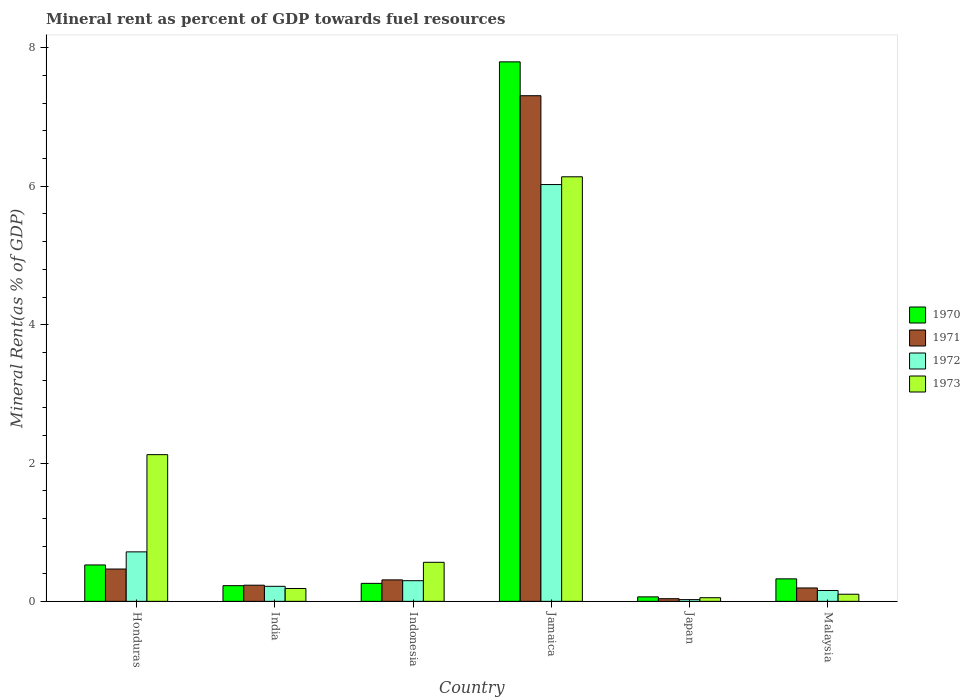How many different coloured bars are there?
Give a very brief answer. 4. What is the label of the 5th group of bars from the left?
Give a very brief answer. Japan. What is the mineral rent in 1971 in India?
Your answer should be very brief. 0.23. Across all countries, what is the maximum mineral rent in 1970?
Your answer should be very brief. 7.8. Across all countries, what is the minimum mineral rent in 1970?
Ensure brevity in your answer.  0.06. In which country was the mineral rent in 1971 maximum?
Provide a short and direct response. Jamaica. What is the total mineral rent in 1970 in the graph?
Keep it short and to the point. 9.2. What is the difference between the mineral rent in 1972 in Jamaica and that in Malaysia?
Offer a very short reply. 5.87. What is the difference between the mineral rent in 1973 in Japan and the mineral rent in 1970 in India?
Your response must be concise. -0.17. What is the average mineral rent in 1970 per country?
Your answer should be compact. 1.53. What is the difference between the mineral rent of/in 1972 and mineral rent of/in 1973 in Malaysia?
Offer a very short reply. 0.05. In how many countries, is the mineral rent in 1970 greater than 6 %?
Your response must be concise. 1. What is the ratio of the mineral rent in 1970 in India to that in Japan?
Give a very brief answer. 3.5. What is the difference between the highest and the second highest mineral rent in 1970?
Your answer should be compact. 0.2. What is the difference between the highest and the lowest mineral rent in 1970?
Your answer should be very brief. 7.73. Is the sum of the mineral rent in 1973 in India and Japan greater than the maximum mineral rent in 1970 across all countries?
Ensure brevity in your answer.  No. Is it the case that in every country, the sum of the mineral rent in 1973 and mineral rent in 1972 is greater than the sum of mineral rent in 1971 and mineral rent in 1970?
Offer a terse response. No. What does the 1st bar from the left in India represents?
Offer a terse response. 1970. Is it the case that in every country, the sum of the mineral rent in 1972 and mineral rent in 1971 is greater than the mineral rent in 1970?
Give a very brief answer. No. Are all the bars in the graph horizontal?
Offer a terse response. No. What is the difference between two consecutive major ticks on the Y-axis?
Offer a terse response. 2. Does the graph contain any zero values?
Your response must be concise. No. Where does the legend appear in the graph?
Offer a very short reply. Center right. How are the legend labels stacked?
Offer a terse response. Vertical. What is the title of the graph?
Offer a very short reply. Mineral rent as percent of GDP towards fuel resources. Does "1977" appear as one of the legend labels in the graph?
Your answer should be very brief. No. What is the label or title of the Y-axis?
Offer a very short reply. Mineral Rent(as % of GDP). What is the Mineral Rent(as % of GDP) of 1970 in Honduras?
Your answer should be compact. 0.53. What is the Mineral Rent(as % of GDP) of 1971 in Honduras?
Keep it short and to the point. 0.47. What is the Mineral Rent(as % of GDP) in 1972 in Honduras?
Provide a succinct answer. 0.72. What is the Mineral Rent(as % of GDP) in 1973 in Honduras?
Offer a terse response. 2.12. What is the Mineral Rent(as % of GDP) of 1970 in India?
Keep it short and to the point. 0.23. What is the Mineral Rent(as % of GDP) of 1971 in India?
Offer a terse response. 0.23. What is the Mineral Rent(as % of GDP) of 1972 in India?
Your response must be concise. 0.22. What is the Mineral Rent(as % of GDP) in 1973 in India?
Offer a terse response. 0.19. What is the Mineral Rent(as % of GDP) of 1970 in Indonesia?
Provide a short and direct response. 0.26. What is the Mineral Rent(as % of GDP) of 1971 in Indonesia?
Ensure brevity in your answer.  0.31. What is the Mineral Rent(as % of GDP) in 1972 in Indonesia?
Give a very brief answer. 0.3. What is the Mineral Rent(as % of GDP) in 1973 in Indonesia?
Your answer should be very brief. 0.56. What is the Mineral Rent(as % of GDP) in 1970 in Jamaica?
Give a very brief answer. 7.8. What is the Mineral Rent(as % of GDP) in 1971 in Jamaica?
Your answer should be very brief. 7.31. What is the Mineral Rent(as % of GDP) in 1972 in Jamaica?
Provide a succinct answer. 6.03. What is the Mineral Rent(as % of GDP) of 1973 in Jamaica?
Provide a short and direct response. 6.14. What is the Mineral Rent(as % of GDP) in 1970 in Japan?
Give a very brief answer. 0.06. What is the Mineral Rent(as % of GDP) of 1971 in Japan?
Provide a short and direct response. 0.04. What is the Mineral Rent(as % of GDP) of 1972 in Japan?
Offer a very short reply. 0.03. What is the Mineral Rent(as % of GDP) of 1973 in Japan?
Provide a short and direct response. 0.05. What is the Mineral Rent(as % of GDP) in 1970 in Malaysia?
Offer a very short reply. 0.33. What is the Mineral Rent(as % of GDP) in 1971 in Malaysia?
Provide a short and direct response. 0.19. What is the Mineral Rent(as % of GDP) in 1972 in Malaysia?
Make the answer very short. 0.16. What is the Mineral Rent(as % of GDP) of 1973 in Malaysia?
Your response must be concise. 0.1. Across all countries, what is the maximum Mineral Rent(as % of GDP) in 1970?
Offer a terse response. 7.8. Across all countries, what is the maximum Mineral Rent(as % of GDP) in 1971?
Provide a short and direct response. 7.31. Across all countries, what is the maximum Mineral Rent(as % of GDP) of 1972?
Offer a very short reply. 6.03. Across all countries, what is the maximum Mineral Rent(as % of GDP) in 1973?
Offer a very short reply. 6.14. Across all countries, what is the minimum Mineral Rent(as % of GDP) in 1970?
Offer a very short reply. 0.06. Across all countries, what is the minimum Mineral Rent(as % of GDP) of 1971?
Provide a succinct answer. 0.04. Across all countries, what is the minimum Mineral Rent(as % of GDP) of 1972?
Your answer should be very brief. 0.03. Across all countries, what is the minimum Mineral Rent(as % of GDP) of 1973?
Give a very brief answer. 0.05. What is the total Mineral Rent(as % of GDP) in 1970 in the graph?
Ensure brevity in your answer.  9.2. What is the total Mineral Rent(as % of GDP) in 1971 in the graph?
Your answer should be very brief. 8.55. What is the total Mineral Rent(as % of GDP) in 1972 in the graph?
Give a very brief answer. 7.44. What is the total Mineral Rent(as % of GDP) of 1973 in the graph?
Make the answer very short. 9.17. What is the difference between the Mineral Rent(as % of GDP) in 1970 in Honduras and that in India?
Offer a very short reply. 0.3. What is the difference between the Mineral Rent(as % of GDP) in 1971 in Honduras and that in India?
Your answer should be very brief. 0.23. What is the difference between the Mineral Rent(as % of GDP) of 1972 in Honduras and that in India?
Make the answer very short. 0.5. What is the difference between the Mineral Rent(as % of GDP) of 1973 in Honduras and that in India?
Offer a very short reply. 1.94. What is the difference between the Mineral Rent(as % of GDP) of 1970 in Honduras and that in Indonesia?
Provide a short and direct response. 0.27. What is the difference between the Mineral Rent(as % of GDP) in 1971 in Honduras and that in Indonesia?
Provide a short and direct response. 0.16. What is the difference between the Mineral Rent(as % of GDP) of 1972 in Honduras and that in Indonesia?
Keep it short and to the point. 0.42. What is the difference between the Mineral Rent(as % of GDP) in 1973 in Honduras and that in Indonesia?
Your answer should be very brief. 1.56. What is the difference between the Mineral Rent(as % of GDP) in 1970 in Honduras and that in Jamaica?
Your response must be concise. -7.27. What is the difference between the Mineral Rent(as % of GDP) in 1971 in Honduras and that in Jamaica?
Make the answer very short. -6.84. What is the difference between the Mineral Rent(as % of GDP) of 1972 in Honduras and that in Jamaica?
Ensure brevity in your answer.  -5.31. What is the difference between the Mineral Rent(as % of GDP) of 1973 in Honduras and that in Jamaica?
Ensure brevity in your answer.  -4.02. What is the difference between the Mineral Rent(as % of GDP) of 1970 in Honduras and that in Japan?
Keep it short and to the point. 0.46. What is the difference between the Mineral Rent(as % of GDP) of 1971 in Honduras and that in Japan?
Provide a succinct answer. 0.43. What is the difference between the Mineral Rent(as % of GDP) of 1972 in Honduras and that in Japan?
Keep it short and to the point. 0.69. What is the difference between the Mineral Rent(as % of GDP) in 1973 in Honduras and that in Japan?
Ensure brevity in your answer.  2.07. What is the difference between the Mineral Rent(as % of GDP) of 1970 in Honduras and that in Malaysia?
Your response must be concise. 0.2. What is the difference between the Mineral Rent(as % of GDP) of 1971 in Honduras and that in Malaysia?
Offer a very short reply. 0.27. What is the difference between the Mineral Rent(as % of GDP) of 1972 in Honduras and that in Malaysia?
Offer a very short reply. 0.56. What is the difference between the Mineral Rent(as % of GDP) in 1973 in Honduras and that in Malaysia?
Your response must be concise. 2.02. What is the difference between the Mineral Rent(as % of GDP) of 1970 in India and that in Indonesia?
Offer a very short reply. -0.03. What is the difference between the Mineral Rent(as % of GDP) of 1971 in India and that in Indonesia?
Provide a short and direct response. -0.08. What is the difference between the Mineral Rent(as % of GDP) in 1972 in India and that in Indonesia?
Give a very brief answer. -0.08. What is the difference between the Mineral Rent(as % of GDP) in 1973 in India and that in Indonesia?
Your answer should be compact. -0.38. What is the difference between the Mineral Rent(as % of GDP) in 1970 in India and that in Jamaica?
Give a very brief answer. -7.57. What is the difference between the Mineral Rent(as % of GDP) of 1971 in India and that in Jamaica?
Offer a terse response. -7.08. What is the difference between the Mineral Rent(as % of GDP) of 1972 in India and that in Jamaica?
Provide a succinct answer. -5.81. What is the difference between the Mineral Rent(as % of GDP) in 1973 in India and that in Jamaica?
Your response must be concise. -5.95. What is the difference between the Mineral Rent(as % of GDP) in 1970 in India and that in Japan?
Your response must be concise. 0.16. What is the difference between the Mineral Rent(as % of GDP) of 1971 in India and that in Japan?
Make the answer very short. 0.2. What is the difference between the Mineral Rent(as % of GDP) in 1972 in India and that in Japan?
Make the answer very short. 0.19. What is the difference between the Mineral Rent(as % of GDP) of 1973 in India and that in Japan?
Your response must be concise. 0.13. What is the difference between the Mineral Rent(as % of GDP) of 1970 in India and that in Malaysia?
Make the answer very short. -0.1. What is the difference between the Mineral Rent(as % of GDP) in 1971 in India and that in Malaysia?
Make the answer very short. 0.04. What is the difference between the Mineral Rent(as % of GDP) in 1972 in India and that in Malaysia?
Your answer should be very brief. 0.06. What is the difference between the Mineral Rent(as % of GDP) of 1973 in India and that in Malaysia?
Ensure brevity in your answer.  0.08. What is the difference between the Mineral Rent(as % of GDP) of 1970 in Indonesia and that in Jamaica?
Ensure brevity in your answer.  -7.54. What is the difference between the Mineral Rent(as % of GDP) of 1971 in Indonesia and that in Jamaica?
Your answer should be compact. -7. What is the difference between the Mineral Rent(as % of GDP) in 1972 in Indonesia and that in Jamaica?
Provide a short and direct response. -5.73. What is the difference between the Mineral Rent(as % of GDP) in 1973 in Indonesia and that in Jamaica?
Keep it short and to the point. -5.57. What is the difference between the Mineral Rent(as % of GDP) of 1970 in Indonesia and that in Japan?
Your answer should be compact. 0.2. What is the difference between the Mineral Rent(as % of GDP) of 1971 in Indonesia and that in Japan?
Make the answer very short. 0.27. What is the difference between the Mineral Rent(as % of GDP) in 1972 in Indonesia and that in Japan?
Your answer should be compact. 0.27. What is the difference between the Mineral Rent(as % of GDP) of 1973 in Indonesia and that in Japan?
Ensure brevity in your answer.  0.51. What is the difference between the Mineral Rent(as % of GDP) of 1970 in Indonesia and that in Malaysia?
Provide a short and direct response. -0.07. What is the difference between the Mineral Rent(as % of GDP) of 1971 in Indonesia and that in Malaysia?
Make the answer very short. 0.12. What is the difference between the Mineral Rent(as % of GDP) of 1972 in Indonesia and that in Malaysia?
Provide a succinct answer. 0.14. What is the difference between the Mineral Rent(as % of GDP) of 1973 in Indonesia and that in Malaysia?
Provide a succinct answer. 0.46. What is the difference between the Mineral Rent(as % of GDP) of 1970 in Jamaica and that in Japan?
Offer a very short reply. 7.73. What is the difference between the Mineral Rent(as % of GDP) of 1971 in Jamaica and that in Japan?
Ensure brevity in your answer.  7.27. What is the difference between the Mineral Rent(as % of GDP) in 1972 in Jamaica and that in Japan?
Offer a terse response. 6. What is the difference between the Mineral Rent(as % of GDP) in 1973 in Jamaica and that in Japan?
Keep it short and to the point. 6.08. What is the difference between the Mineral Rent(as % of GDP) in 1970 in Jamaica and that in Malaysia?
Offer a very short reply. 7.47. What is the difference between the Mineral Rent(as % of GDP) of 1971 in Jamaica and that in Malaysia?
Offer a terse response. 7.12. What is the difference between the Mineral Rent(as % of GDP) in 1972 in Jamaica and that in Malaysia?
Your answer should be very brief. 5.87. What is the difference between the Mineral Rent(as % of GDP) of 1973 in Jamaica and that in Malaysia?
Your response must be concise. 6.03. What is the difference between the Mineral Rent(as % of GDP) of 1970 in Japan and that in Malaysia?
Give a very brief answer. -0.26. What is the difference between the Mineral Rent(as % of GDP) of 1971 in Japan and that in Malaysia?
Provide a succinct answer. -0.16. What is the difference between the Mineral Rent(as % of GDP) of 1972 in Japan and that in Malaysia?
Your answer should be very brief. -0.13. What is the difference between the Mineral Rent(as % of GDP) in 1973 in Japan and that in Malaysia?
Your answer should be compact. -0.05. What is the difference between the Mineral Rent(as % of GDP) of 1970 in Honduras and the Mineral Rent(as % of GDP) of 1971 in India?
Your answer should be very brief. 0.29. What is the difference between the Mineral Rent(as % of GDP) in 1970 in Honduras and the Mineral Rent(as % of GDP) in 1972 in India?
Make the answer very short. 0.31. What is the difference between the Mineral Rent(as % of GDP) in 1970 in Honduras and the Mineral Rent(as % of GDP) in 1973 in India?
Offer a terse response. 0.34. What is the difference between the Mineral Rent(as % of GDP) of 1971 in Honduras and the Mineral Rent(as % of GDP) of 1972 in India?
Ensure brevity in your answer.  0.25. What is the difference between the Mineral Rent(as % of GDP) in 1971 in Honduras and the Mineral Rent(as % of GDP) in 1973 in India?
Your answer should be very brief. 0.28. What is the difference between the Mineral Rent(as % of GDP) of 1972 in Honduras and the Mineral Rent(as % of GDP) of 1973 in India?
Provide a short and direct response. 0.53. What is the difference between the Mineral Rent(as % of GDP) of 1970 in Honduras and the Mineral Rent(as % of GDP) of 1971 in Indonesia?
Your response must be concise. 0.22. What is the difference between the Mineral Rent(as % of GDP) of 1970 in Honduras and the Mineral Rent(as % of GDP) of 1972 in Indonesia?
Your response must be concise. 0.23. What is the difference between the Mineral Rent(as % of GDP) in 1970 in Honduras and the Mineral Rent(as % of GDP) in 1973 in Indonesia?
Keep it short and to the point. -0.04. What is the difference between the Mineral Rent(as % of GDP) in 1971 in Honduras and the Mineral Rent(as % of GDP) in 1972 in Indonesia?
Provide a succinct answer. 0.17. What is the difference between the Mineral Rent(as % of GDP) of 1971 in Honduras and the Mineral Rent(as % of GDP) of 1973 in Indonesia?
Provide a succinct answer. -0.1. What is the difference between the Mineral Rent(as % of GDP) of 1972 in Honduras and the Mineral Rent(as % of GDP) of 1973 in Indonesia?
Make the answer very short. 0.15. What is the difference between the Mineral Rent(as % of GDP) in 1970 in Honduras and the Mineral Rent(as % of GDP) in 1971 in Jamaica?
Ensure brevity in your answer.  -6.78. What is the difference between the Mineral Rent(as % of GDP) of 1970 in Honduras and the Mineral Rent(as % of GDP) of 1972 in Jamaica?
Give a very brief answer. -5.5. What is the difference between the Mineral Rent(as % of GDP) of 1970 in Honduras and the Mineral Rent(as % of GDP) of 1973 in Jamaica?
Offer a very short reply. -5.61. What is the difference between the Mineral Rent(as % of GDP) in 1971 in Honduras and the Mineral Rent(as % of GDP) in 1972 in Jamaica?
Ensure brevity in your answer.  -5.56. What is the difference between the Mineral Rent(as % of GDP) of 1971 in Honduras and the Mineral Rent(as % of GDP) of 1973 in Jamaica?
Your answer should be compact. -5.67. What is the difference between the Mineral Rent(as % of GDP) in 1972 in Honduras and the Mineral Rent(as % of GDP) in 1973 in Jamaica?
Offer a very short reply. -5.42. What is the difference between the Mineral Rent(as % of GDP) of 1970 in Honduras and the Mineral Rent(as % of GDP) of 1971 in Japan?
Offer a terse response. 0.49. What is the difference between the Mineral Rent(as % of GDP) of 1970 in Honduras and the Mineral Rent(as % of GDP) of 1972 in Japan?
Ensure brevity in your answer.  0.5. What is the difference between the Mineral Rent(as % of GDP) in 1970 in Honduras and the Mineral Rent(as % of GDP) in 1973 in Japan?
Your response must be concise. 0.47. What is the difference between the Mineral Rent(as % of GDP) of 1971 in Honduras and the Mineral Rent(as % of GDP) of 1972 in Japan?
Your answer should be compact. 0.44. What is the difference between the Mineral Rent(as % of GDP) in 1971 in Honduras and the Mineral Rent(as % of GDP) in 1973 in Japan?
Provide a succinct answer. 0.41. What is the difference between the Mineral Rent(as % of GDP) in 1972 in Honduras and the Mineral Rent(as % of GDP) in 1973 in Japan?
Your answer should be compact. 0.66. What is the difference between the Mineral Rent(as % of GDP) in 1970 in Honduras and the Mineral Rent(as % of GDP) in 1971 in Malaysia?
Offer a very short reply. 0.33. What is the difference between the Mineral Rent(as % of GDP) in 1970 in Honduras and the Mineral Rent(as % of GDP) in 1972 in Malaysia?
Keep it short and to the point. 0.37. What is the difference between the Mineral Rent(as % of GDP) in 1970 in Honduras and the Mineral Rent(as % of GDP) in 1973 in Malaysia?
Keep it short and to the point. 0.42. What is the difference between the Mineral Rent(as % of GDP) in 1971 in Honduras and the Mineral Rent(as % of GDP) in 1972 in Malaysia?
Your response must be concise. 0.31. What is the difference between the Mineral Rent(as % of GDP) in 1971 in Honduras and the Mineral Rent(as % of GDP) in 1973 in Malaysia?
Your response must be concise. 0.36. What is the difference between the Mineral Rent(as % of GDP) in 1972 in Honduras and the Mineral Rent(as % of GDP) in 1973 in Malaysia?
Offer a very short reply. 0.61. What is the difference between the Mineral Rent(as % of GDP) of 1970 in India and the Mineral Rent(as % of GDP) of 1971 in Indonesia?
Offer a very short reply. -0.08. What is the difference between the Mineral Rent(as % of GDP) of 1970 in India and the Mineral Rent(as % of GDP) of 1972 in Indonesia?
Give a very brief answer. -0.07. What is the difference between the Mineral Rent(as % of GDP) of 1970 in India and the Mineral Rent(as % of GDP) of 1973 in Indonesia?
Offer a very short reply. -0.34. What is the difference between the Mineral Rent(as % of GDP) in 1971 in India and the Mineral Rent(as % of GDP) in 1972 in Indonesia?
Give a very brief answer. -0.07. What is the difference between the Mineral Rent(as % of GDP) in 1971 in India and the Mineral Rent(as % of GDP) in 1973 in Indonesia?
Make the answer very short. -0.33. What is the difference between the Mineral Rent(as % of GDP) in 1972 in India and the Mineral Rent(as % of GDP) in 1973 in Indonesia?
Give a very brief answer. -0.35. What is the difference between the Mineral Rent(as % of GDP) of 1970 in India and the Mineral Rent(as % of GDP) of 1971 in Jamaica?
Offer a very short reply. -7.08. What is the difference between the Mineral Rent(as % of GDP) in 1970 in India and the Mineral Rent(as % of GDP) in 1972 in Jamaica?
Keep it short and to the point. -5.8. What is the difference between the Mineral Rent(as % of GDP) of 1970 in India and the Mineral Rent(as % of GDP) of 1973 in Jamaica?
Your answer should be compact. -5.91. What is the difference between the Mineral Rent(as % of GDP) of 1971 in India and the Mineral Rent(as % of GDP) of 1972 in Jamaica?
Make the answer very short. -5.79. What is the difference between the Mineral Rent(as % of GDP) in 1971 in India and the Mineral Rent(as % of GDP) in 1973 in Jamaica?
Keep it short and to the point. -5.9. What is the difference between the Mineral Rent(as % of GDP) in 1972 in India and the Mineral Rent(as % of GDP) in 1973 in Jamaica?
Your answer should be very brief. -5.92. What is the difference between the Mineral Rent(as % of GDP) in 1970 in India and the Mineral Rent(as % of GDP) in 1971 in Japan?
Provide a succinct answer. 0.19. What is the difference between the Mineral Rent(as % of GDP) of 1970 in India and the Mineral Rent(as % of GDP) of 1972 in Japan?
Provide a short and direct response. 0.2. What is the difference between the Mineral Rent(as % of GDP) of 1970 in India and the Mineral Rent(as % of GDP) of 1973 in Japan?
Your response must be concise. 0.17. What is the difference between the Mineral Rent(as % of GDP) in 1971 in India and the Mineral Rent(as % of GDP) in 1972 in Japan?
Your response must be concise. 0.21. What is the difference between the Mineral Rent(as % of GDP) in 1971 in India and the Mineral Rent(as % of GDP) in 1973 in Japan?
Give a very brief answer. 0.18. What is the difference between the Mineral Rent(as % of GDP) of 1972 in India and the Mineral Rent(as % of GDP) of 1973 in Japan?
Your answer should be very brief. 0.16. What is the difference between the Mineral Rent(as % of GDP) in 1970 in India and the Mineral Rent(as % of GDP) in 1972 in Malaysia?
Make the answer very short. 0.07. What is the difference between the Mineral Rent(as % of GDP) of 1970 in India and the Mineral Rent(as % of GDP) of 1973 in Malaysia?
Your answer should be compact. 0.12. What is the difference between the Mineral Rent(as % of GDP) of 1971 in India and the Mineral Rent(as % of GDP) of 1972 in Malaysia?
Your answer should be compact. 0.08. What is the difference between the Mineral Rent(as % of GDP) in 1971 in India and the Mineral Rent(as % of GDP) in 1973 in Malaysia?
Make the answer very short. 0.13. What is the difference between the Mineral Rent(as % of GDP) in 1972 in India and the Mineral Rent(as % of GDP) in 1973 in Malaysia?
Provide a short and direct response. 0.11. What is the difference between the Mineral Rent(as % of GDP) of 1970 in Indonesia and the Mineral Rent(as % of GDP) of 1971 in Jamaica?
Your answer should be compact. -7.05. What is the difference between the Mineral Rent(as % of GDP) in 1970 in Indonesia and the Mineral Rent(as % of GDP) in 1972 in Jamaica?
Offer a terse response. -5.77. What is the difference between the Mineral Rent(as % of GDP) in 1970 in Indonesia and the Mineral Rent(as % of GDP) in 1973 in Jamaica?
Offer a terse response. -5.88. What is the difference between the Mineral Rent(as % of GDP) of 1971 in Indonesia and the Mineral Rent(as % of GDP) of 1972 in Jamaica?
Your answer should be compact. -5.72. What is the difference between the Mineral Rent(as % of GDP) in 1971 in Indonesia and the Mineral Rent(as % of GDP) in 1973 in Jamaica?
Offer a very short reply. -5.83. What is the difference between the Mineral Rent(as % of GDP) of 1972 in Indonesia and the Mineral Rent(as % of GDP) of 1973 in Jamaica?
Keep it short and to the point. -5.84. What is the difference between the Mineral Rent(as % of GDP) in 1970 in Indonesia and the Mineral Rent(as % of GDP) in 1971 in Japan?
Your answer should be very brief. 0.22. What is the difference between the Mineral Rent(as % of GDP) in 1970 in Indonesia and the Mineral Rent(as % of GDP) in 1972 in Japan?
Keep it short and to the point. 0.23. What is the difference between the Mineral Rent(as % of GDP) of 1970 in Indonesia and the Mineral Rent(as % of GDP) of 1973 in Japan?
Offer a terse response. 0.21. What is the difference between the Mineral Rent(as % of GDP) in 1971 in Indonesia and the Mineral Rent(as % of GDP) in 1972 in Japan?
Keep it short and to the point. 0.29. What is the difference between the Mineral Rent(as % of GDP) in 1971 in Indonesia and the Mineral Rent(as % of GDP) in 1973 in Japan?
Keep it short and to the point. 0.26. What is the difference between the Mineral Rent(as % of GDP) of 1972 in Indonesia and the Mineral Rent(as % of GDP) of 1973 in Japan?
Give a very brief answer. 0.25. What is the difference between the Mineral Rent(as % of GDP) of 1970 in Indonesia and the Mineral Rent(as % of GDP) of 1971 in Malaysia?
Give a very brief answer. 0.07. What is the difference between the Mineral Rent(as % of GDP) of 1970 in Indonesia and the Mineral Rent(as % of GDP) of 1972 in Malaysia?
Your response must be concise. 0.1. What is the difference between the Mineral Rent(as % of GDP) in 1970 in Indonesia and the Mineral Rent(as % of GDP) in 1973 in Malaysia?
Offer a very short reply. 0.16. What is the difference between the Mineral Rent(as % of GDP) of 1971 in Indonesia and the Mineral Rent(as % of GDP) of 1972 in Malaysia?
Make the answer very short. 0.15. What is the difference between the Mineral Rent(as % of GDP) of 1971 in Indonesia and the Mineral Rent(as % of GDP) of 1973 in Malaysia?
Keep it short and to the point. 0.21. What is the difference between the Mineral Rent(as % of GDP) in 1972 in Indonesia and the Mineral Rent(as % of GDP) in 1973 in Malaysia?
Your answer should be very brief. 0.2. What is the difference between the Mineral Rent(as % of GDP) in 1970 in Jamaica and the Mineral Rent(as % of GDP) in 1971 in Japan?
Make the answer very short. 7.76. What is the difference between the Mineral Rent(as % of GDP) in 1970 in Jamaica and the Mineral Rent(as % of GDP) in 1972 in Japan?
Give a very brief answer. 7.77. What is the difference between the Mineral Rent(as % of GDP) of 1970 in Jamaica and the Mineral Rent(as % of GDP) of 1973 in Japan?
Your answer should be compact. 7.75. What is the difference between the Mineral Rent(as % of GDP) of 1971 in Jamaica and the Mineral Rent(as % of GDP) of 1972 in Japan?
Keep it short and to the point. 7.28. What is the difference between the Mineral Rent(as % of GDP) in 1971 in Jamaica and the Mineral Rent(as % of GDP) in 1973 in Japan?
Keep it short and to the point. 7.26. What is the difference between the Mineral Rent(as % of GDP) of 1972 in Jamaica and the Mineral Rent(as % of GDP) of 1973 in Japan?
Give a very brief answer. 5.97. What is the difference between the Mineral Rent(as % of GDP) of 1970 in Jamaica and the Mineral Rent(as % of GDP) of 1971 in Malaysia?
Your response must be concise. 7.61. What is the difference between the Mineral Rent(as % of GDP) of 1970 in Jamaica and the Mineral Rent(as % of GDP) of 1972 in Malaysia?
Provide a short and direct response. 7.64. What is the difference between the Mineral Rent(as % of GDP) in 1970 in Jamaica and the Mineral Rent(as % of GDP) in 1973 in Malaysia?
Provide a short and direct response. 7.7. What is the difference between the Mineral Rent(as % of GDP) in 1971 in Jamaica and the Mineral Rent(as % of GDP) in 1972 in Malaysia?
Give a very brief answer. 7.15. What is the difference between the Mineral Rent(as % of GDP) in 1971 in Jamaica and the Mineral Rent(as % of GDP) in 1973 in Malaysia?
Your response must be concise. 7.21. What is the difference between the Mineral Rent(as % of GDP) in 1972 in Jamaica and the Mineral Rent(as % of GDP) in 1973 in Malaysia?
Your answer should be compact. 5.92. What is the difference between the Mineral Rent(as % of GDP) of 1970 in Japan and the Mineral Rent(as % of GDP) of 1971 in Malaysia?
Provide a short and direct response. -0.13. What is the difference between the Mineral Rent(as % of GDP) in 1970 in Japan and the Mineral Rent(as % of GDP) in 1972 in Malaysia?
Make the answer very short. -0.09. What is the difference between the Mineral Rent(as % of GDP) of 1970 in Japan and the Mineral Rent(as % of GDP) of 1973 in Malaysia?
Keep it short and to the point. -0.04. What is the difference between the Mineral Rent(as % of GDP) in 1971 in Japan and the Mineral Rent(as % of GDP) in 1972 in Malaysia?
Ensure brevity in your answer.  -0.12. What is the difference between the Mineral Rent(as % of GDP) of 1971 in Japan and the Mineral Rent(as % of GDP) of 1973 in Malaysia?
Ensure brevity in your answer.  -0.06. What is the difference between the Mineral Rent(as % of GDP) in 1972 in Japan and the Mineral Rent(as % of GDP) in 1973 in Malaysia?
Make the answer very short. -0.08. What is the average Mineral Rent(as % of GDP) in 1970 per country?
Provide a succinct answer. 1.53. What is the average Mineral Rent(as % of GDP) in 1971 per country?
Offer a very short reply. 1.43. What is the average Mineral Rent(as % of GDP) in 1972 per country?
Offer a very short reply. 1.24. What is the average Mineral Rent(as % of GDP) in 1973 per country?
Keep it short and to the point. 1.53. What is the difference between the Mineral Rent(as % of GDP) in 1970 and Mineral Rent(as % of GDP) in 1971 in Honduras?
Give a very brief answer. 0.06. What is the difference between the Mineral Rent(as % of GDP) in 1970 and Mineral Rent(as % of GDP) in 1972 in Honduras?
Keep it short and to the point. -0.19. What is the difference between the Mineral Rent(as % of GDP) of 1970 and Mineral Rent(as % of GDP) of 1973 in Honduras?
Make the answer very short. -1.59. What is the difference between the Mineral Rent(as % of GDP) in 1971 and Mineral Rent(as % of GDP) in 1972 in Honduras?
Offer a terse response. -0.25. What is the difference between the Mineral Rent(as % of GDP) of 1971 and Mineral Rent(as % of GDP) of 1973 in Honduras?
Ensure brevity in your answer.  -1.65. What is the difference between the Mineral Rent(as % of GDP) of 1972 and Mineral Rent(as % of GDP) of 1973 in Honduras?
Offer a very short reply. -1.41. What is the difference between the Mineral Rent(as % of GDP) of 1970 and Mineral Rent(as % of GDP) of 1971 in India?
Keep it short and to the point. -0.01. What is the difference between the Mineral Rent(as % of GDP) in 1970 and Mineral Rent(as % of GDP) in 1972 in India?
Provide a short and direct response. 0.01. What is the difference between the Mineral Rent(as % of GDP) of 1970 and Mineral Rent(as % of GDP) of 1973 in India?
Keep it short and to the point. 0.04. What is the difference between the Mineral Rent(as % of GDP) in 1971 and Mineral Rent(as % of GDP) in 1972 in India?
Provide a short and direct response. 0.02. What is the difference between the Mineral Rent(as % of GDP) in 1971 and Mineral Rent(as % of GDP) in 1973 in India?
Provide a succinct answer. 0.05. What is the difference between the Mineral Rent(as % of GDP) in 1972 and Mineral Rent(as % of GDP) in 1973 in India?
Your answer should be very brief. 0.03. What is the difference between the Mineral Rent(as % of GDP) in 1970 and Mineral Rent(as % of GDP) in 1971 in Indonesia?
Provide a short and direct response. -0.05. What is the difference between the Mineral Rent(as % of GDP) in 1970 and Mineral Rent(as % of GDP) in 1972 in Indonesia?
Offer a terse response. -0.04. What is the difference between the Mineral Rent(as % of GDP) of 1970 and Mineral Rent(as % of GDP) of 1973 in Indonesia?
Give a very brief answer. -0.3. What is the difference between the Mineral Rent(as % of GDP) in 1971 and Mineral Rent(as % of GDP) in 1972 in Indonesia?
Provide a short and direct response. 0.01. What is the difference between the Mineral Rent(as % of GDP) in 1971 and Mineral Rent(as % of GDP) in 1973 in Indonesia?
Make the answer very short. -0.25. What is the difference between the Mineral Rent(as % of GDP) in 1972 and Mineral Rent(as % of GDP) in 1973 in Indonesia?
Make the answer very short. -0.27. What is the difference between the Mineral Rent(as % of GDP) in 1970 and Mineral Rent(as % of GDP) in 1971 in Jamaica?
Your answer should be very brief. 0.49. What is the difference between the Mineral Rent(as % of GDP) in 1970 and Mineral Rent(as % of GDP) in 1972 in Jamaica?
Offer a terse response. 1.77. What is the difference between the Mineral Rent(as % of GDP) of 1970 and Mineral Rent(as % of GDP) of 1973 in Jamaica?
Provide a short and direct response. 1.66. What is the difference between the Mineral Rent(as % of GDP) of 1971 and Mineral Rent(as % of GDP) of 1972 in Jamaica?
Provide a succinct answer. 1.28. What is the difference between the Mineral Rent(as % of GDP) in 1971 and Mineral Rent(as % of GDP) in 1973 in Jamaica?
Offer a terse response. 1.17. What is the difference between the Mineral Rent(as % of GDP) in 1972 and Mineral Rent(as % of GDP) in 1973 in Jamaica?
Offer a terse response. -0.11. What is the difference between the Mineral Rent(as % of GDP) of 1970 and Mineral Rent(as % of GDP) of 1971 in Japan?
Offer a terse response. 0.03. What is the difference between the Mineral Rent(as % of GDP) of 1970 and Mineral Rent(as % of GDP) of 1972 in Japan?
Your answer should be compact. 0.04. What is the difference between the Mineral Rent(as % of GDP) of 1970 and Mineral Rent(as % of GDP) of 1973 in Japan?
Offer a very short reply. 0.01. What is the difference between the Mineral Rent(as % of GDP) of 1971 and Mineral Rent(as % of GDP) of 1972 in Japan?
Your answer should be compact. 0.01. What is the difference between the Mineral Rent(as % of GDP) of 1971 and Mineral Rent(as % of GDP) of 1973 in Japan?
Offer a terse response. -0.01. What is the difference between the Mineral Rent(as % of GDP) in 1972 and Mineral Rent(as % of GDP) in 1973 in Japan?
Offer a terse response. -0.03. What is the difference between the Mineral Rent(as % of GDP) of 1970 and Mineral Rent(as % of GDP) of 1971 in Malaysia?
Ensure brevity in your answer.  0.13. What is the difference between the Mineral Rent(as % of GDP) of 1970 and Mineral Rent(as % of GDP) of 1972 in Malaysia?
Make the answer very short. 0.17. What is the difference between the Mineral Rent(as % of GDP) in 1970 and Mineral Rent(as % of GDP) in 1973 in Malaysia?
Offer a terse response. 0.22. What is the difference between the Mineral Rent(as % of GDP) in 1971 and Mineral Rent(as % of GDP) in 1972 in Malaysia?
Offer a very short reply. 0.04. What is the difference between the Mineral Rent(as % of GDP) of 1971 and Mineral Rent(as % of GDP) of 1973 in Malaysia?
Provide a short and direct response. 0.09. What is the difference between the Mineral Rent(as % of GDP) in 1972 and Mineral Rent(as % of GDP) in 1973 in Malaysia?
Your answer should be compact. 0.05. What is the ratio of the Mineral Rent(as % of GDP) of 1970 in Honduras to that in India?
Your answer should be compact. 2.32. What is the ratio of the Mineral Rent(as % of GDP) in 1971 in Honduras to that in India?
Provide a short and direct response. 2. What is the ratio of the Mineral Rent(as % of GDP) of 1972 in Honduras to that in India?
Ensure brevity in your answer.  3.29. What is the ratio of the Mineral Rent(as % of GDP) in 1973 in Honduras to that in India?
Make the answer very short. 11.41. What is the ratio of the Mineral Rent(as % of GDP) in 1970 in Honduras to that in Indonesia?
Your answer should be compact. 2.02. What is the ratio of the Mineral Rent(as % of GDP) in 1971 in Honduras to that in Indonesia?
Your answer should be very brief. 1.51. What is the ratio of the Mineral Rent(as % of GDP) of 1972 in Honduras to that in Indonesia?
Offer a very short reply. 2.4. What is the ratio of the Mineral Rent(as % of GDP) of 1973 in Honduras to that in Indonesia?
Keep it short and to the point. 3.76. What is the ratio of the Mineral Rent(as % of GDP) of 1970 in Honduras to that in Jamaica?
Keep it short and to the point. 0.07. What is the ratio of the Mineral Rent(as % of GDP) of 1971 in Honduras to that in Jamaica?
Make the answer very short. 0.06. What is the ratio of the Mineral Rent(as % of GDP) in 1972 in Honduras to that in Jamaica?
Ensure brevity in your answer.  0.12. What is the ratio of the Mineral Rent(as % of GDP) in 1973 in Honduras to that in Jamaica?
Ensure brevity in your answer.  0.35. What is the ratio of the Mineral Rent(as % of GDP) of 1970 in Honduras to that in Japan?
Make the answer very short. 8.11. What is the ratio of the Mineral Rent(as % of GDP) of 1971 in Honduras to that in Japan?
Keep it short and to the point. 12.13. What is the ratio of the Mineral Rent(as % of GDP) of 1972 in Honduras to that in Japan?
Offer a terse response. 28.32. What is the ratio of the Mineral Rent(as % of GDP) of 1973 in Honduras to that in Japan?
Keep it short and to the point. 40.15. What is the ratio of the Mineral Rent(as % of GDP) in 1970 in Honduras to that in Malaysia?
Provide a succinct answer. 1.62. What is the ratio of the Mineral Rent(as % of GDP) of 1971 in Honduras to that in Malaysia?
Provide a short and direct response. 2.41. What is the ratio of the Mineral Rent(as % of GDP) of 1972 in Honduras to that in Malaysia?
Ensure brevity in your answer.  4.56. What is the ratio of the Mineral Rent(as % of GDP) in 1973 in Honduras to that in Malaysia?
Your answer should be compact. 20.56. What is the ratio of the Mineral Rent(as % of GDP) of 1970 in India to that in Indonesia?
Give a very brief answer. 0.87. What is the ratio of the Mineral Rent(as % of GDP) in 1971 in India to that in Indonesia?
Give a very brief answer. 0.75. What is the ratio of the Mineral Rent(as % of GDP) of 1972 in India to that in Indonesia?
Your response must be concise. 0.73. What is the ratio of the Mineral Rent(as % of GDP) of 1973 in India to that in Indonesia?
Ensure brevity in your answer.  0.33. What is the ratio of the Mineral Rent(as % of GDP) in 1970 in India to that in Jamaica?
Provide a short and direct response. 0.03. What is the ratio of the Mineral Rent(as % of GDP) in 1971 in India to that in Jamaica?
Your answer should be compact. 0.03. What is the ratio of the Mineral Rent(as % of GDP) in 1972 in India to that in Jamaica?
Ensure brevity in your answer.  0.04. What is the ratio of the Mineral Rent(as % of GDP) in 1973 in India to that in Jamaica?
Keep it short and to the point. 0.03. What is the ratio of the Mineral Rent(as % of GDP) of 1970 in India to that in Japan?
Offer a terse response. 3.5. What is the ratio of the Mineral Rent(as % of GDP) of 1971 in India to that in Japan?
Make the answer very short. 6.06. What is the ratio of the Mineral Rent(as % of GDP) of 1972 in India to that in Japan?
Provide a short and direct response. 8.6. What is the ratio of the Mineral Rent(as % of GDP) of 1973 in India to that in Japan?
Your response must be concise. 3.52. What is the ratio of the Mineral Rent(as % of GDP) in 1970 in India to that in Malaysia?
Keep it short and to the point. 0.7. What is the ratio of the Mineral Rent(as % of GDP) in 1971 in India to that in Malaysia?
Your response must be concise. 1.21. What is the ratio of the Mineral Rent(as % of GDP) in 1972 in India to that in Malaysia?
Offer a very short reply. 1.38. What is the ratio of the Mineral Rent(as % of GDP) of 1973 in India to that in Malaysia?
Make the answer very short. 1.8. What is the ratio of the Mineral Rent(as % of GDP) of 1971 in Indonesia to that in Jamaica?
Give a very brief answer. 0.04. What is the ratio of the Mineral Rent(as % of GDP) of 1972 in Indonesia to that in Jamaica?
Provide a short and direct response. 0.05. What is the ratio of the Mineral Rent(as % of GDP) of 1973 in Indonesia to that in Jamaica?
Keep it short and to the point. 0.09. What is the ratio of the Mineral Rent(as % of GDP) of 1970 in Indonesia to that in Japan?
Provide a short and direct response. 4.01. What is the ratio of the Mineral Rent(as % of GDP) in 1971 in Indonesia to that in Japan?
Offer a terse response. 8.06. What is the ratio of the Mineral Rent(as % of GDP) of 1972 in Indonesia to that in Japan?
Ensure brevity in your answer.  11.82. What is the ratio of the Mineral Rent(as % of GDP) of 1973 in Indonesia to that in Japan?
Ensure brevity in your answer.  10.69. What is the ratio of the Mineral Rent(as % of GDP) in 1970 in Indonesia to that in Malaysia?
Offer a terse response. 0.8. What is the ratio of the Mineral Rent(as % of GDP) of 1971 in Indonesia to that in Malaysia?
Offer a very short reply. 1.6. What is the ratio of the Mineral Rent(as % of GDP) in 1972 in Indonesia to that in Malaysia?
Make the answer very short. 1.9. What is the ratio of the Mineral Rent(as % of GDP) in 1973 in Indonesia to that in Malaysia?
Make the answer very short. 5.47. What is the ratio of the Mineral Rent(as % of GDP) in 1970 in Jamaica to that in Japan?
Keep it short and to the point. 120.23. What is the ratio of the Mineral Rent(as % of GDP) of 1971 in Jamaica to that in Japan?
Your answer should be compact. 189.73. What is the ratio of the Mineral Rent(as % of GDP) of 1972 in Jamaica to that in Japan?
Your answer should be very brief. 238.51. What is the ratio of the Mineral Rent(as % of GDP) in 1973 in Jamaica to that in Japan?
Provide a short and direct response. 116.18. What is the ratio of the Mineral Rent(as % of GDP) in 1970 in Jamaica to that in Malaysia?
Provide a succinct answer. 23.97. What is the ratio of the Mineral Rent(as % of GDP) of 1971 in Jamaica to that in Malaysia?
Your answer should be compact. 37.76. What is the ratio of the Mineral Rent(as % of GDP) of 1972 in Jamaica to that in Malaysia?
Provide a short and direct response. 38.36. What is the ratio of the Mineral Rent(as % of GDP) of 1973 in Jamaica to that in Malaysia?
Offer a very short reply. 59.49. What is the ratio of the Mineral Rent(as % of GDP) in 1970 in Japan to that in Malaysia?
Your answer should be compact. 0.2. What is the ratio of the Mineral Rent(as % of GDP) in 1971 in Japan to that in Malaysia?
Ensure brevity in your answer.  0.2. What is the ratio of the Mineral Rent(as % of GDP) of 1972 in Japan to that in Malaysia?
Offer a very short reply. 0.16. What is the ratio of the Mineral Rent(as % of GDP) of 1973 in Japan to that in Malaysia?
Give a very brief answer. 0.51. What is the difference between the highest and the second highest Mineral Rent(as % of GDP) of 1970?
Offer a very short reply. 7.27. What is the difference between the highest and the second highest Mineral Rent(as % of GDP) of 1971?
Keep it short and to the point. 6.84. What is the difference between the highest and the second highest Mineral Rent(as % of GDP) of 1972?
Ensure brevity in your answer.  5.31. What is the difference between the highest and the second highest Mineral Rent(as % of GDP) in 1973?
Offer a very short reply. 4.02. What is the difference between the highest and the lowest Mineral Rent(as % of GDP) in 1970?
Your answer should be compact. 7.73. What is the difference between the highest and the lowest Mineral Rent(as % of GDP) in 1971?
Your answer should be compact. 7.27. What is the difference between the highest and the lowest Mineral Rent(as % of GDP) in 1972?
Provide a short and direct response. 6. What is the difference between the highest and the lowest Mineral Rent(as % of GDP) in 1973?
Provide a short and direct response. 6.08. 